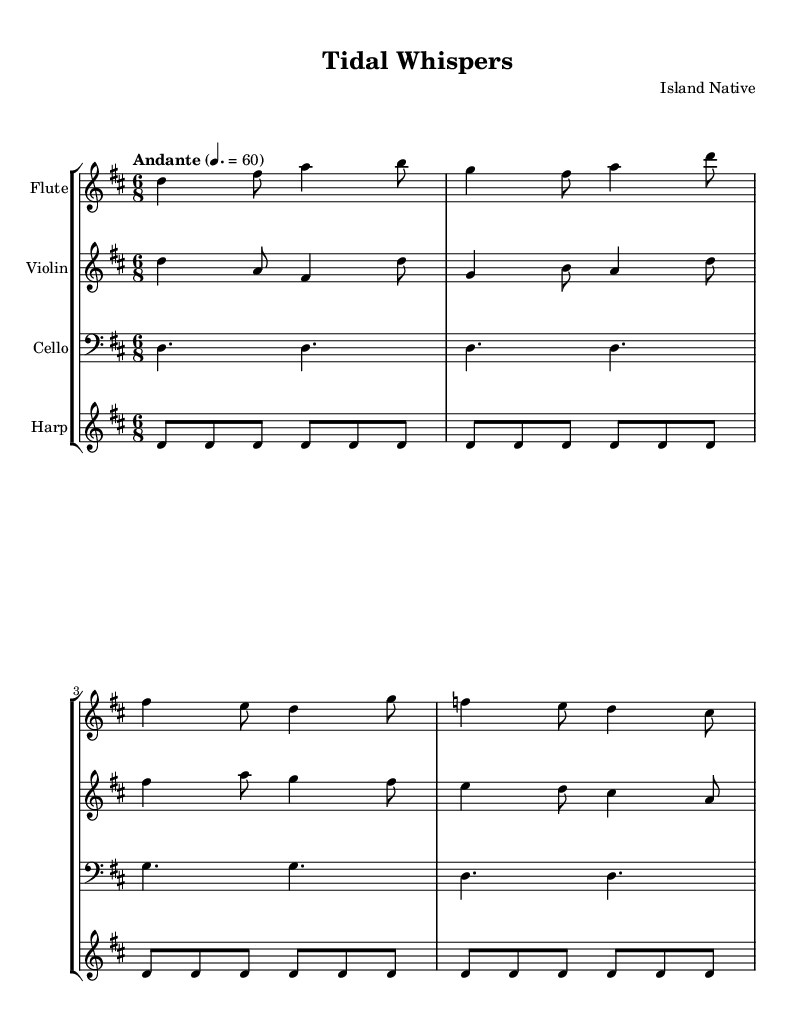What is the key signature of this music? The key signature is two sharps, which corresponds to D major. This can be identified by looking at the key signature at the beginning of the staff.
Answer: D major What is the time signature of this piece? The time signature is 6/8. This is indicated by the notation at the beginning of the score, which shows a "6" over an "8".
Answer: 6/8 What is the tempo marking for this composition? The tempo marking indicates "Andante" with a metronome marking of 60. This is explicitly stated above the staff in the tempo indication.
Answer: Andante, 60 Which instruments are featured in this piece? The instruments featured are Flute, Violin, Cello, and Harp. This can be derived from the staff labels indicated at the beginning of each staff in the score.
Answer: Flute, Violin, Cello, Harp How many measures are in the flute part? The flute part contains 4 measures, which can be counted by observing the grouping of notes and the bar lines that separate these measures in the score.
Answer: 4 What type of rhythm predominates in the cello part? The cello part predominantly features dotted half notes. This is observed by examining the note types written in the cello line, which consist of a series of double dotted notes.
Answer: Dotted half notes Does the harp play a continuous pattern? Yes, the harp plays a continuous pattern, repeating the notes as indicated in the score. This is identified by the repeat sign in the harp part, which shows that the same sequence is played multiple times.
Answer: Yes 